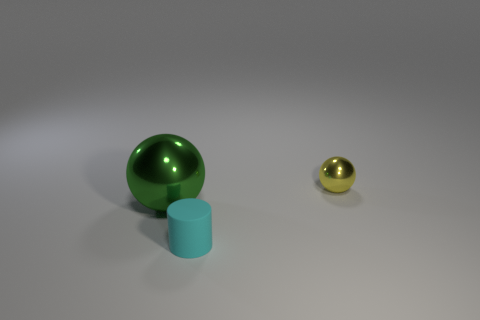Is there anything else that has the same material as the big sphere?
Ensure brevity in your answer.  Yes. Is there anything else that is the same size as the green metallic object?
Give a very brief answer. No. Are there any other things that are the same shape as the rubber thing?
Make the answer very short. No. There is another big object that is the same material as the yellow thing; what is its shape?
Offer a terse response. Sphere. There is a metal thing that is to the left of the small yellow metal thing; what is its shape?
Provide a succinct answer. Sphere. Are there any other things that have the same color as the big shiny ball?
Your answer should be compact. No. Is the number of cyan matte objects to the left of the tiny cyan rubber object less than the number of tiny green matte blocks?
Ensure brevity in your answer.  No. What number of yellow metallic objects are the same size as the matte cylinder?
Keep it short and to the point. 1. There is a thing that is in front of the sphere that is left of the cylinder on the left side of the tiny yellow thing; what is its shape?
Your answer should be compact. Cylinder. There is a sphere that is right of the tiny cyan thing; what color is it?
Offer a very short reply. Yellow. 